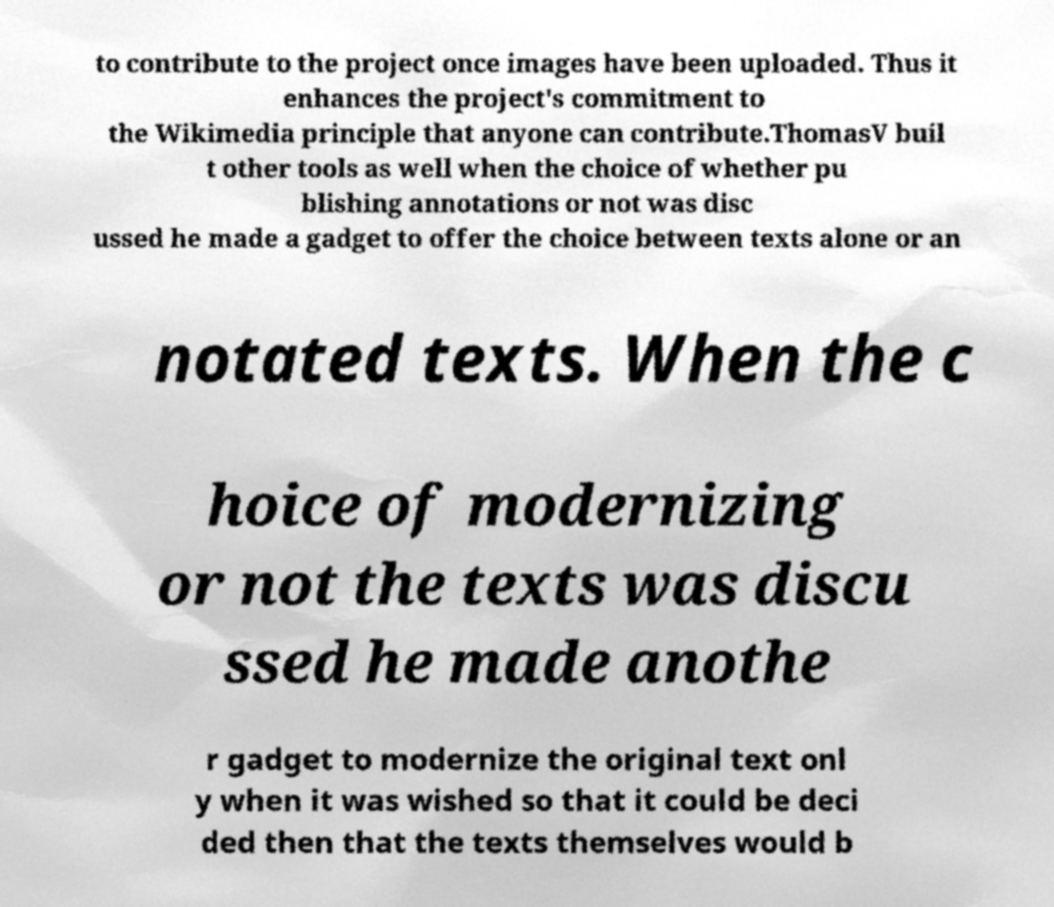For documentation purposes, I need the text within this image transcribed. Could you provide that? to contribute to the project once images have been uploaded. Thus it enhances the project's commitment to the Wikimedia principle that anyone can contribute.ThomasV buil t other tools as well when the choice of whether pu blishing annotations or not was disc ussed he made a gadget to offer the choice between texts alone or an notated texts. When the c hoice of modernizing or not the texts was discu ssed he made anothe r gadget to modernize the original text onl y when it was wished so that it could be deci ded then that the texts themselves would b 